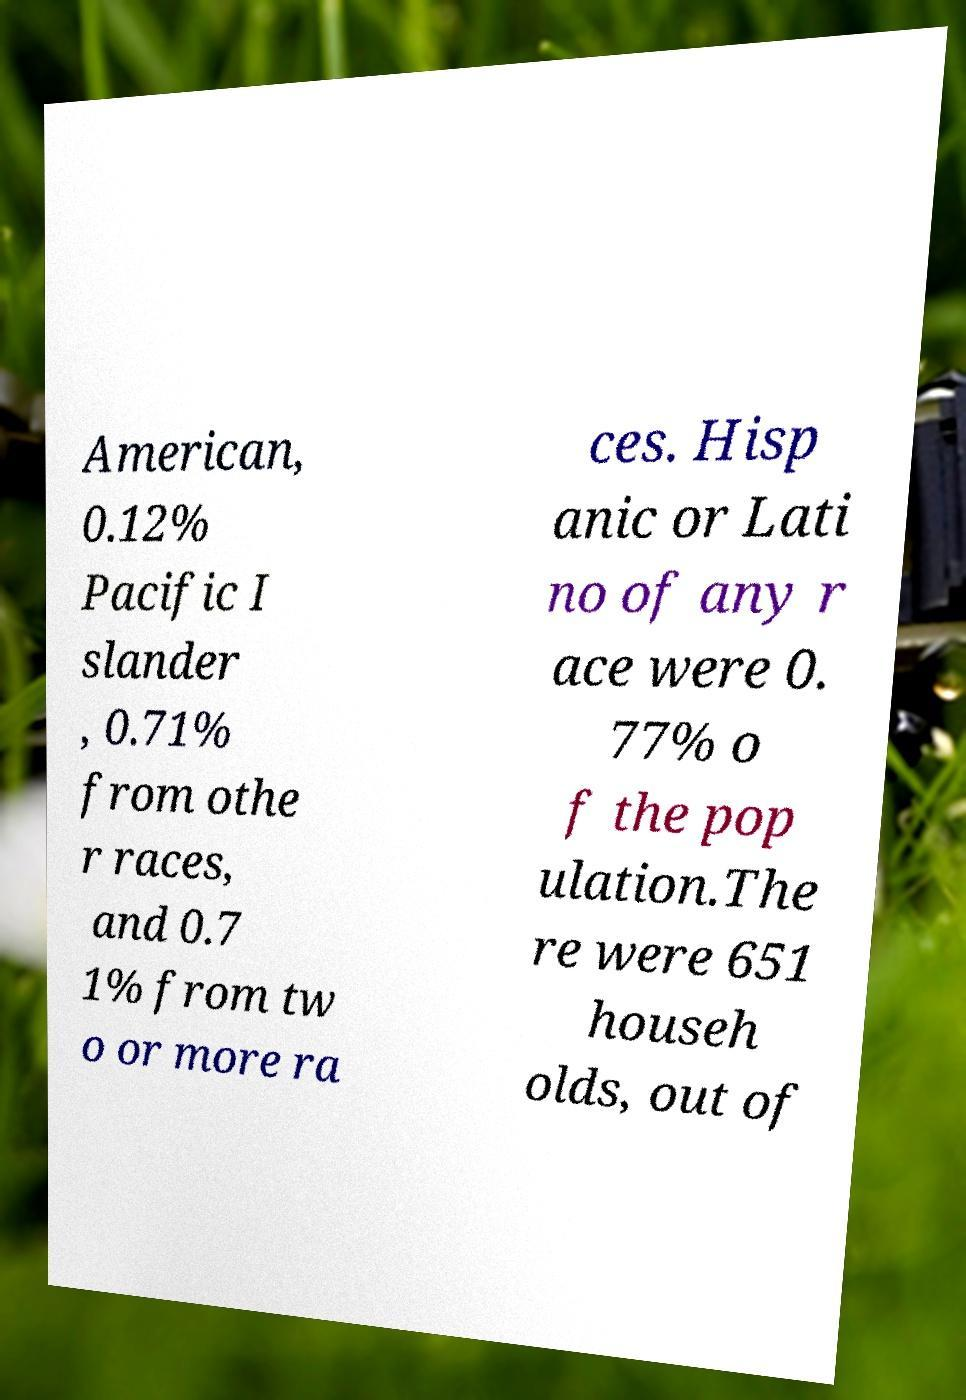Please identify and transcribe the text found in this image. American, 0.12% Pacific I slander , 0.71% from othe r races, and 0.7 1% from tw o or more ra ces. Hisp anic or Lati no of any r ace were 0. 77% o f the pop ulation.The re were 651 househ olds, out of 